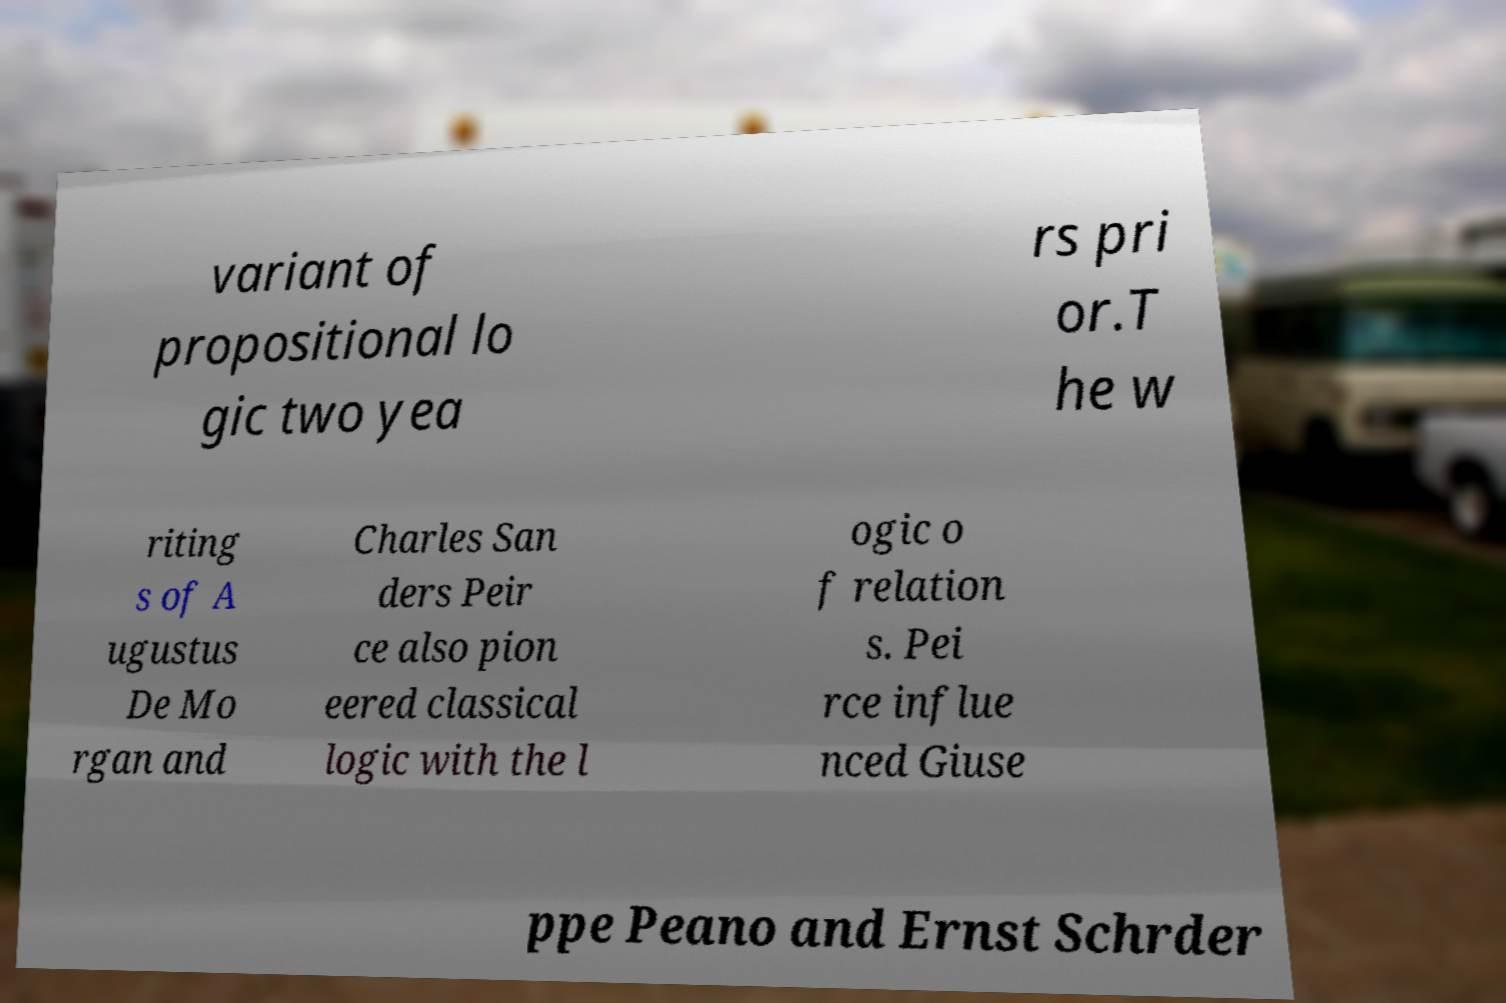Can you accurately transcribe the text from the provided image for me? variant of propositional lo gic two yea rs pri or.T he w riting s of A ugustus De Mo rgan and Charles San ders Peir ce also pion eered classical logic with the l ogic o f relation s. Pei rce influe nced Giuse ppe Peano and Ernst Schrder 